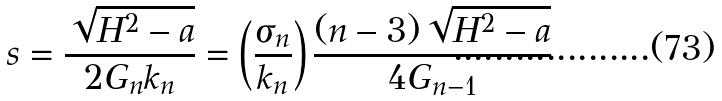<formula> <loc_0><loc_0><loc_500><loc_500>s = \frac { \sqrt { H ^ { 2 } - a } } { 2 G _ { n } k _ { n } } = \left ( \frac { \sigma _ { n } } { k _ { n } } \right ) \frac { ( n - 3 ) \sqrt { H ^ { 2 } - a } } { 4 G _ { n - 1 } }</formula> 